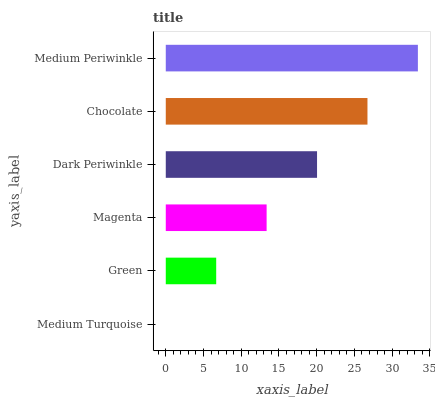Is Medium Turquoise the minimum?
Answer yes or no. Yes. Is Medium Periwinkle the maximum?
Answer yes or no. Yes. Is Green the minimum?
Answer yes or no. No. Is Green the maximum?
Answer yes or no. No. Is Green greater than Medium Turquoise?
Answer yes or no. Yes. Is Medium Turquoise less than Green?
Answer yes or no. Yes. Is Medium Turquoise greater than Green?
Answer yes or no. No. Is Green less than Medium Turquoise?
Answer yes or no. No. Is Dark Periwinkle the high median?
Answer yes or no. Yes. Is Magenta the low median?
Answer yes or no. Yes. Is Green the high median?
Answer yes or no. No. Is Medium Periwinkle the low median?
Answer yes or no. No. 